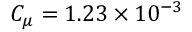<formula> <loc_0><loc_0><loc_500><loc_500>C _ { \mu } = 1 . 2 3 \times 1 0 ^ { - 3 }</formula> 